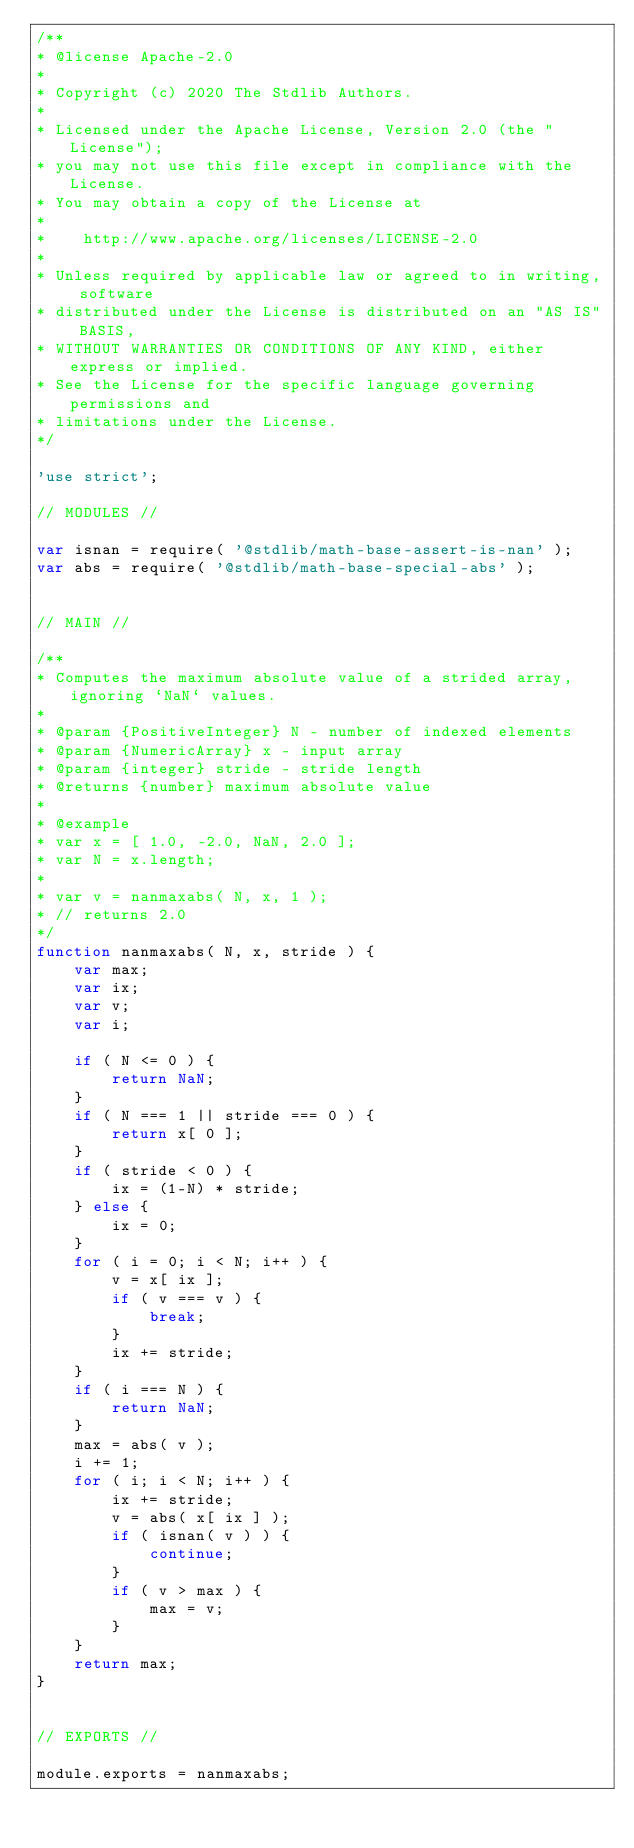Convert code to text. <code><loc_0><loc_0><loc_500><loc_500><_JavaScript_>/**
* @license Apache-2.0
*
* Copyright (c) 2020 The Stdlib Authors.
*
* Licensed under the Apache License, Version 2.0 (the "License");
* you may not use this file except in compliance with the License.
* You may obtain a copy of the License at
*
*    http://www.apache.org/licenses/LICENSE-2.0
*
* Unless required by applicable law or agreed to in writing, software
* distributed under the License is distributed on an "AS IS" BASIS,
* WITHOUT WARRANTIES OR CONDITIONS OF ANY KIND, either express or implied.
* See the License for the specific language governing permissions and
* limitations under the License.
*/

'use strict';

// MODULES //

var isnan = require( '@stdlib/math-base-assert-is-nan' );
var abs = require( '@stdlib/math-base-special-abs' );


// MAIN //

/**
* Computes the maximum absolute value of a strided array, ignoring `NaN` values.
*
* @param {PositiveInteger} N - number of indexed elements
* @param {NumericArray} x - input array
* @param {integer} stride - stride length
* @returns {number} maximum absolute value
*
* @example
* var x = [ 1.0, -2.0, NaN, 2.0 ];
* var N = x.length;
*
* var v = nanmaxabs( N, x, 1 );
* // returns 2.0
*/
function nanmaxabs( N, x, stride ) {
	var max;
	var ix;
	var v;
	var i;

	if ( N <= 0 ) {
		return NaN;
	}
	if ( N === 1 || stride === 0 ) {
		return x[ 0 ];
	}
	if ( stride < 0 ) {
		ix = (1-N) * stride;
	} else {
		ix = 0;
	}
	for ( i = 0; i < N; i++ ) {
		v = x[ ix ];
		if ( v === v ) {
			break;
		}
		ix += stride;
	}
	if ( i === N ) {
		return NaN;
	}
	max = abs( v );
	i += 1;
	for ( i; i < N; i++ ) {
		ix += stride;
		v = abs( x[ ix ] );
		if ( isnan( v ) ) {
			continue;
		}
		if ( v > max ) {
			max = v;
		}
	}
	return max;
}


// EXPORTS //

module.exports = nanmaxabs;
</code> 